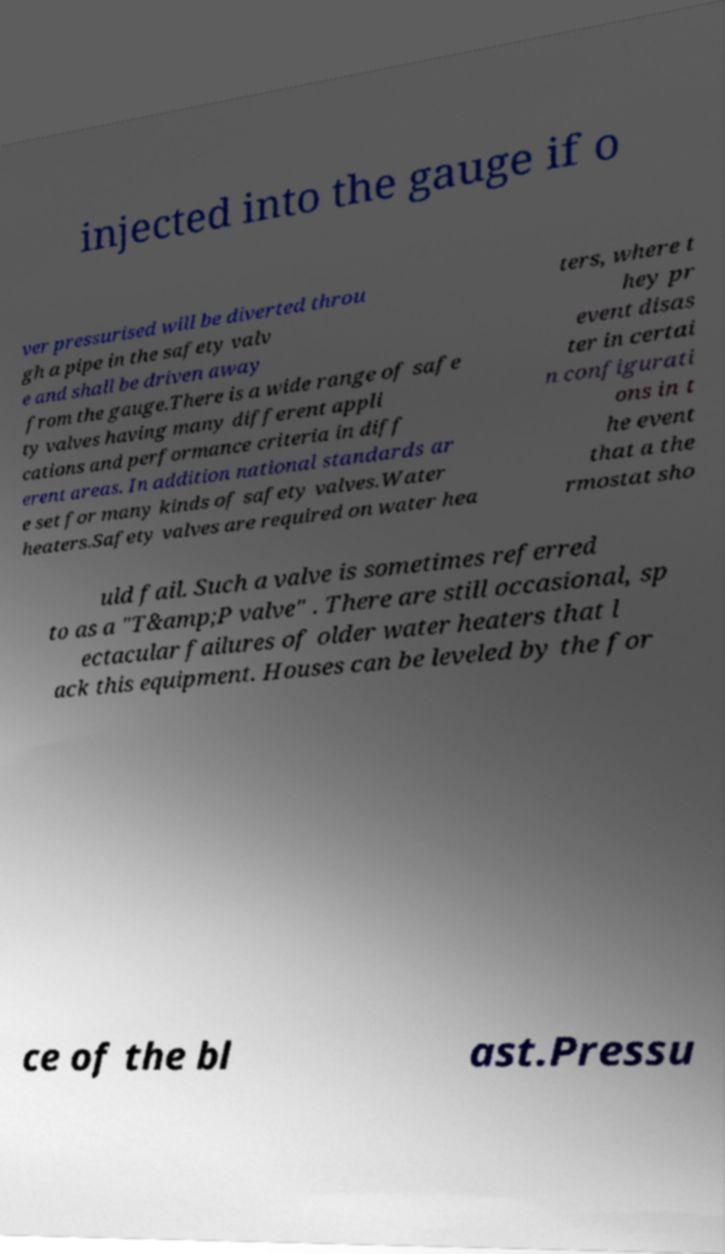Can you read and provide the text displayed in the image?This photo seems to have some interesting text. Can you extract and type it out for me? injected into the gauge if o ver pressurised will be diverted throu gh a pipe in the safety valv e and shall be driven away from the gauge.There is a wide range of safe ty valves having many different appli cations and performance criteria in diff erent areas. In addition national standards ar e set for many kinds of safety valves.Water heaters.Safety valves are required on water hea ters, where t hey pr event disas ter in certai n configurati ons in t he event that a the rmostat sho uld fail. Such a valve is sometimes referred to as a "T&amp;P valve" . There are still occasional, sp ectacular failures of older water heaters that l ack this equipment. Houses can be leveled by the for ce of the bl ast.Pressu 